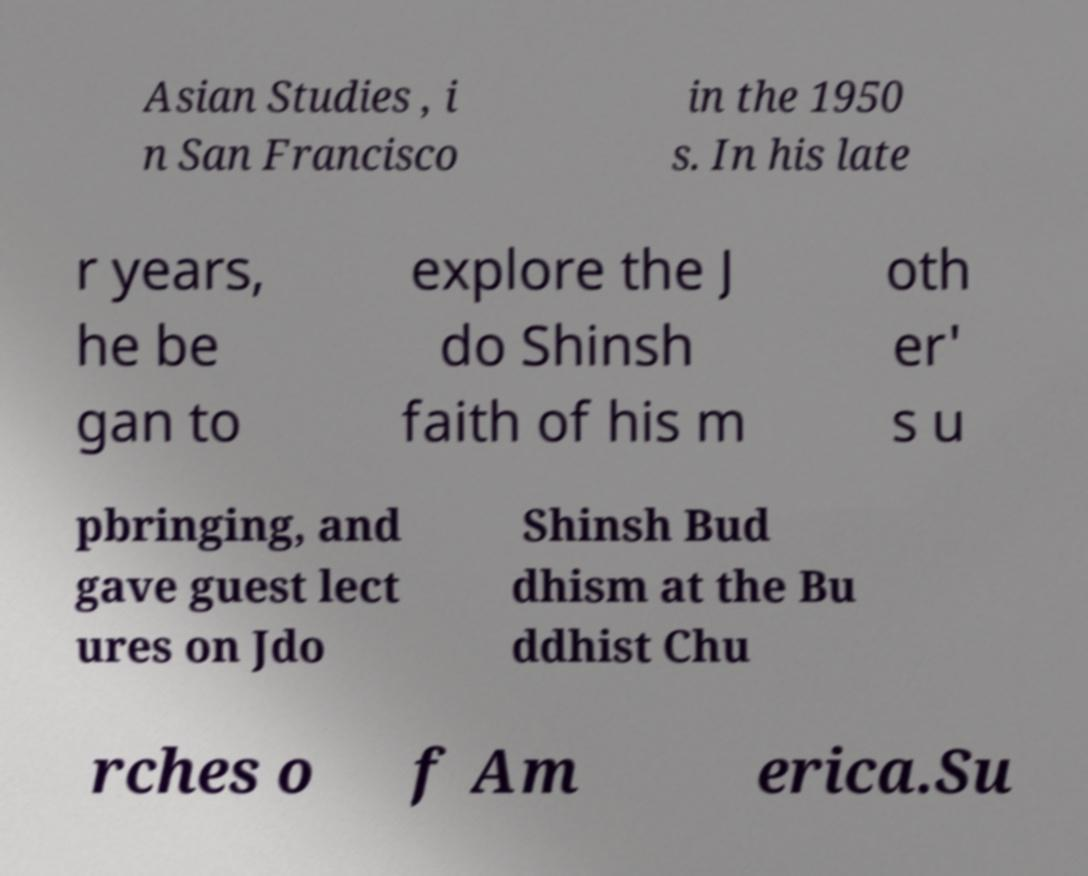Could you assist in decoding the text presented in this image and type it out clearly? Asian Studies , i n San Francisco in the 1950 s. In his late r years, he be gan to explore the J do Shinsh faith of his m oth er' s u pbringing, and gave guest lect ures on Jdo Shinsh Bud dhism at the Bu ddhist Chu rches o f Am erica.Su 